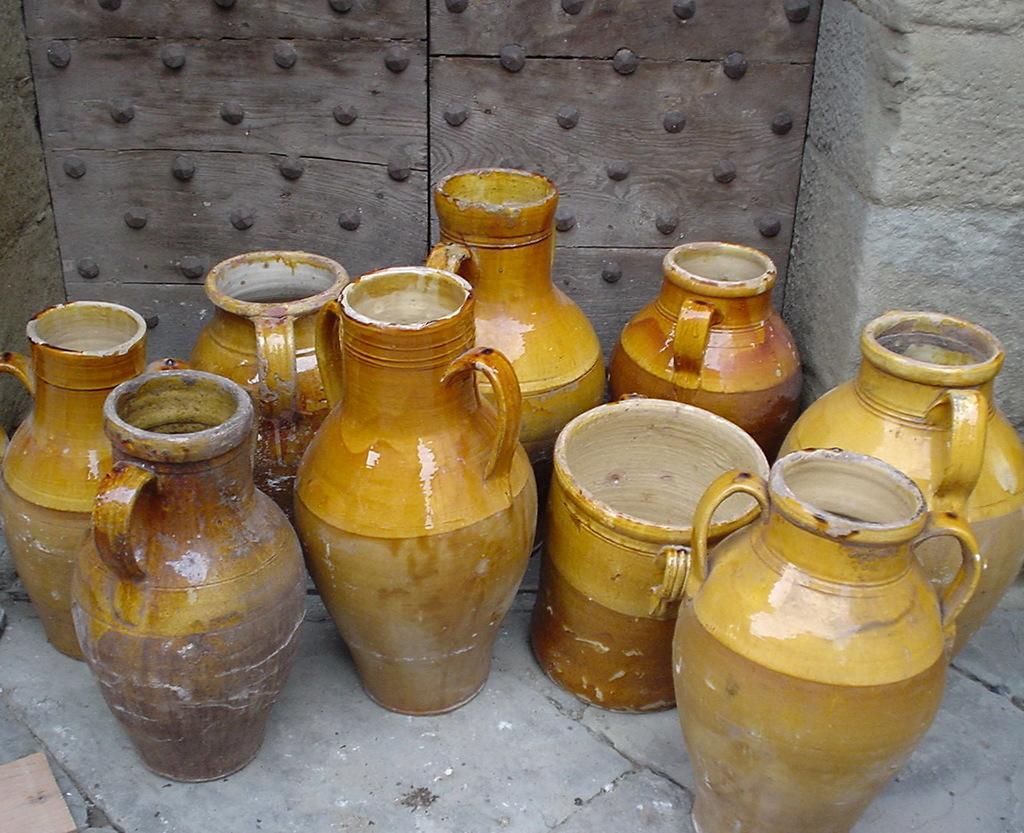How would you summarize this image in a sentence or two? In this image I can see few cases which are in brown color. In the back I can see the wooden door and the wall. I can see some nails to the wooden door. 